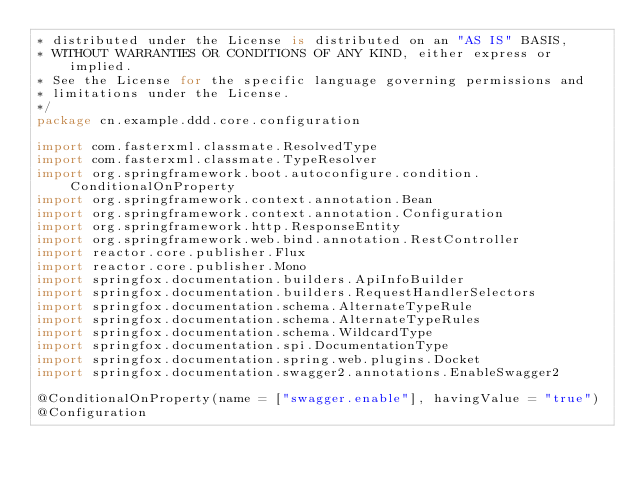<code> <loc_0><loc_0><loc_500><loc_500><_Kotlin_>* distributed under the License is distributed on an "AS IS" BASIS,
* WITHOUT WARRANTIES OR CONDITIONS OF ANY KIND, either express or implied.
* See the License for the specific language governing permissions and
* limitations under the License.
*/
package cn.example.ddd.core.configuration

import com.fasterxml.classmate.ResolvedType
import com.fasterxml.classmate.TypeResolver
import org.springframework.boot.autoconfigure.condition.ConditionalOnProperty
import org.springframework.context.annotation.Bean
import org.springframework.context.annotation.Configuration
import org.springframework.http.ResponseEntity
import org.springframework.web.bind.annotation.RestController
import reactor.core.publisher.Flux
import reactor.core.publisher.Mono
import springfox.documentation.builders.ApiInfoBuilder
import springfox.documentation.builders.RequestHandlerSelectors
import springfox.documentation.schema.AlternateTypeRule
import springfox.documentation.schema.AlternateTypeRules
import springfox.documentation.schema.WildcardType
import springfox.documentation.spi.DocumentationType
import springfox.documentation.spring.web.plugins.Docket
import springfox.documentation.swagger2.annotations.EnableSwagger2

@ConditionalOnProperty(name = ["swagger.enable"], havingValue = "true")
@Configuration</code> 